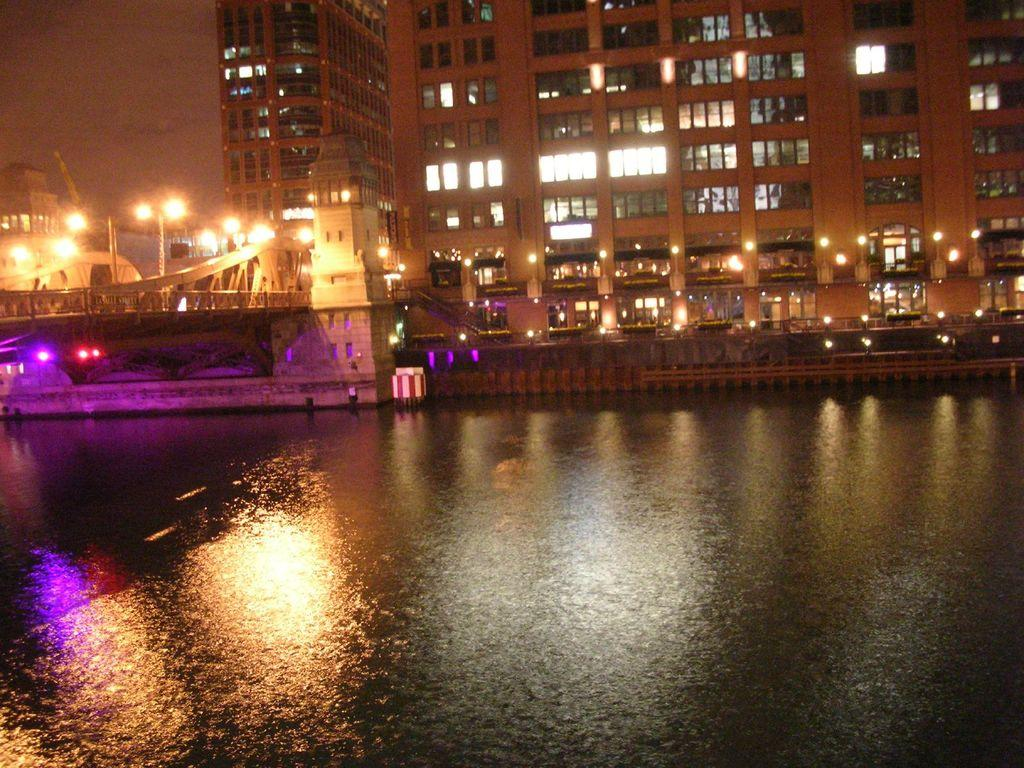What is the primary element present in the image? There is water in the image. What structure can be seen crossing over the water? There is a bridge in the image. What can be seen illuminating the scene in the image? There are lights visible in the image. What type of man-made structures are present in the image? There are buildings in the image. How many balls can be seen floating in the water in the image? There are no balls present in the image; it features water, a bridge, lights, and buildings. Are there any potato plants visible in the image? There are no potato plants present in the image. 